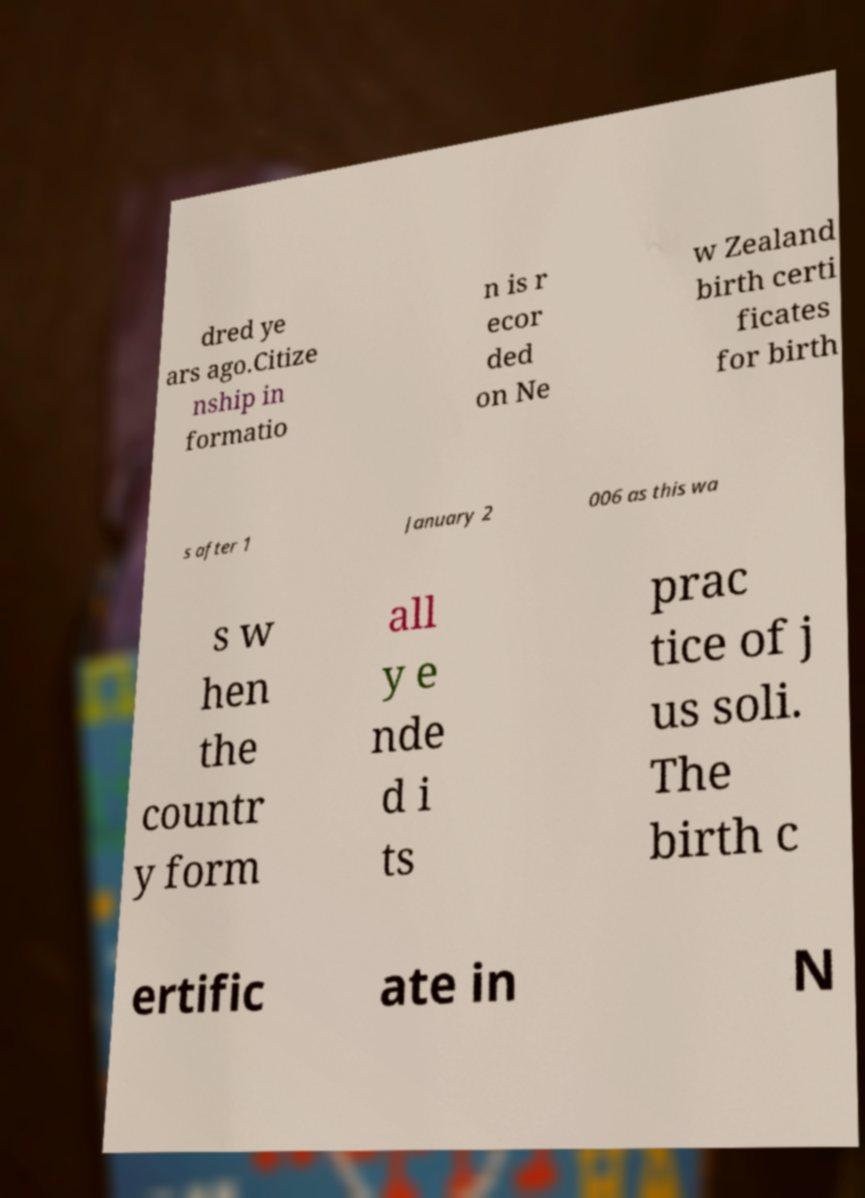Could you assist in decoding the text presented in this image and type it out clearly? dred ye ars ago.Citize nship in formatio n is r ecor ded on Ne w Zealand birth certi ficates for birth s after 1 January 2 006 as this wa s w hen the countr y form all y e nde d i ts prac tice of j us soli. The birth c ertific ate in N 